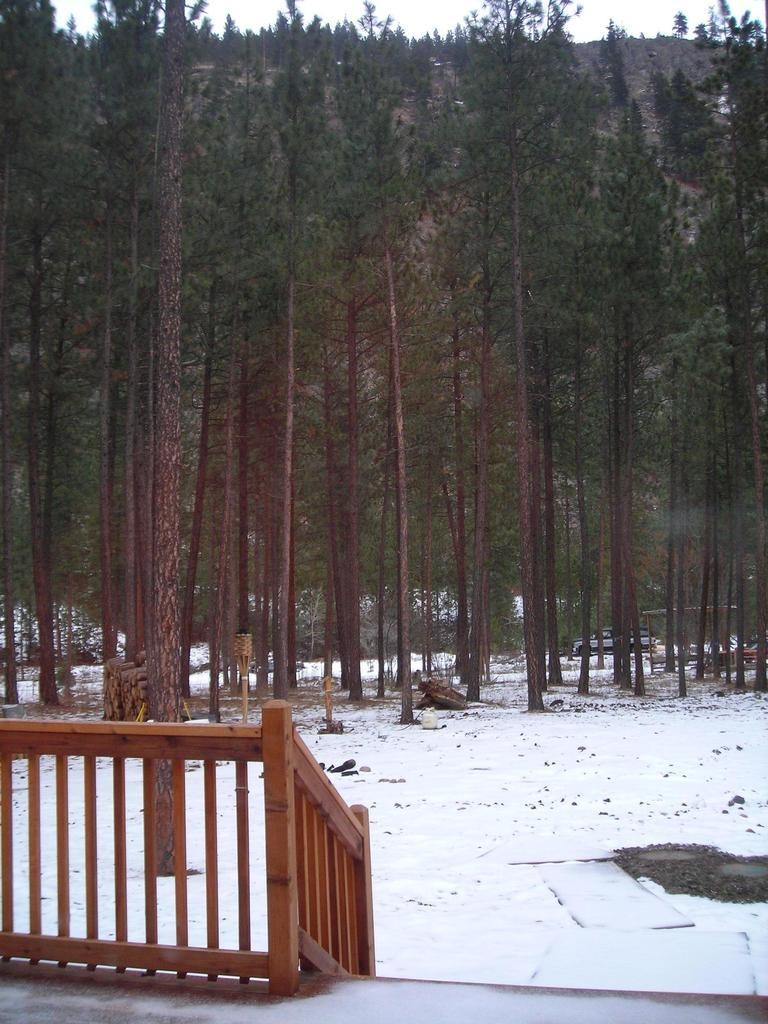What type of structure can be seen on the left side of the image? There is a wooden railing on the left side of the image. What can be seen in the background of the image? There are trees and the sky visible in the background of the image. What is the building's expansion plan in the image? There is no building present in the image, so it is not possible to discuss an expansion plan. 